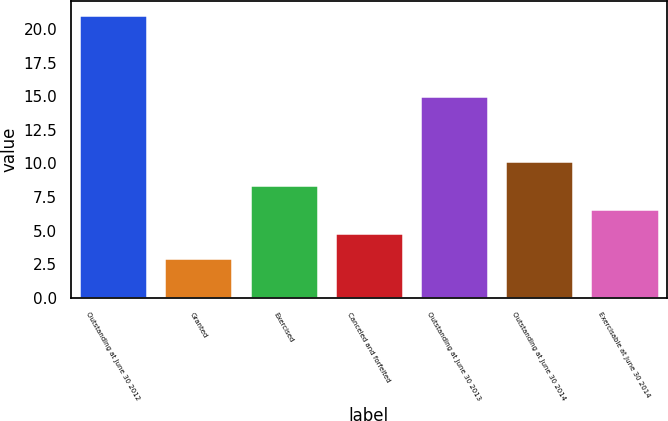<chart> <loc_0><loc_0><loc_500><loc_500><bar_chart><fcel>Outstanding at June 30 2012<fcel>Granted<fcel>Exercised<fcel>Canceled and forfeited<fcel>Outstanding at June 30 2013<fcel>Outstanding at June 30 2014<fcel>Exercisable at June 30 2014<nl><fcel>21<fcel>3<fcel>8.4<fcel>4.8<fcel>15<fcel>10.2<fcel>6.6<nl></chart> 